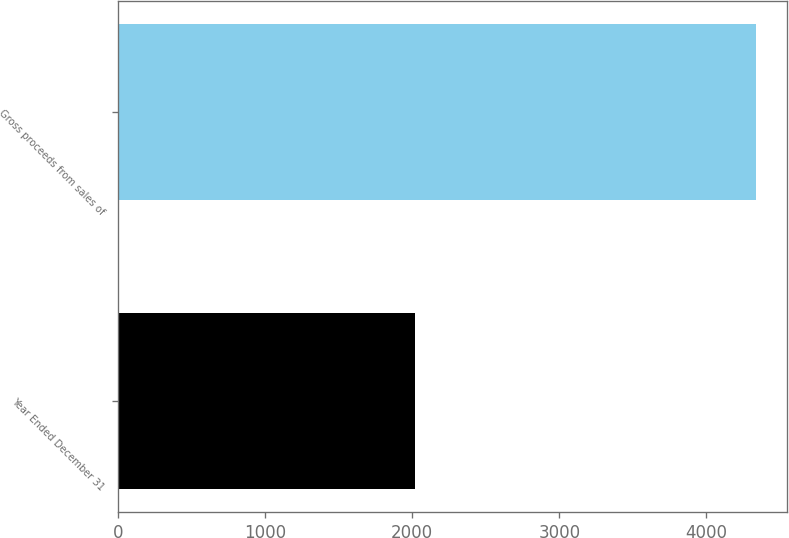Convert chart. <chart><loc_0><loc_0><loc_500><loc_500><bar_chart><fcel>Year Ended December 31<fcel>Gross proceeds from sales of<nl><fcel>2016<fcel>4335<nl></chart> 